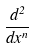Convert formula to latex. <formula><loc_0><loc_0><loc_500><loc_500>\frac { d ^ { 2 } } { d x ^ { n } }</formula> 